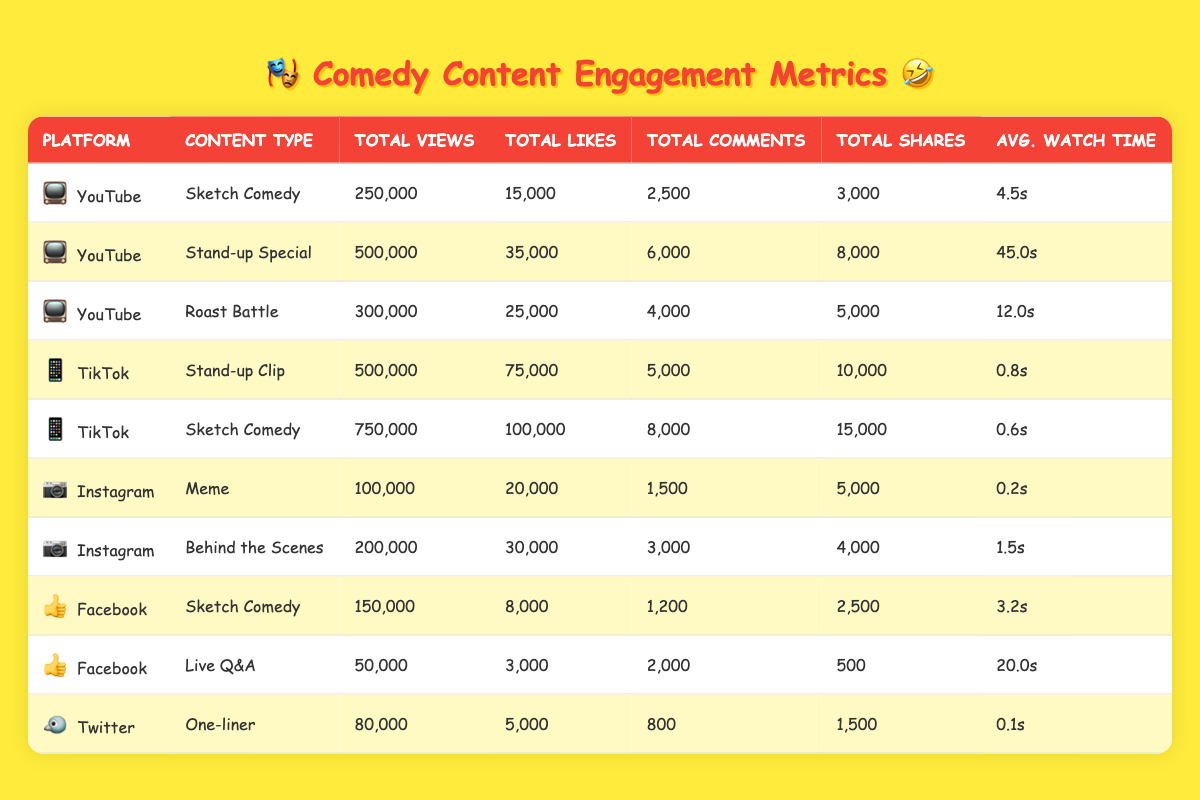What is the total number of views for TikTok content? From the data, the TikTok content consists of two entries: one for "When Your Cat Judges You" with 500,000 views and another for "Mace & Burton's TikTok Dance Fail," which has 750,000 views. Adding these two together gives 500,000 + 750,000 = 1,250,000 views.
Answer: 1,250,000 Which content type received the highest number of likes? The likes data shows that the TikTok sketch comedy video "Mace & Burton's TikTok Dance Fail" received 100,000 likes, which is more than any other content type in the table. The next highest is the YouTube stand-up clip with 75,000 likes. Thus, the highest likes were 100,000.
Answer: 100,000 Did any video receive more than 1,000 shares, and if so, which one had the highest shares? Checking the shares column, the TikTok sketch comedy video has 15,000 shares, which is significantly higher than the others, all of which also exceed 1,000 shares. The video "Mace & Burton's TikTok Dance Fail" holds the highest with 15,000 shares.
Answer: Yes, "Mace & Burton's TikTok Dance Fail" had the highest shares with 15,000 What is the average watch time for YouTube content? The YouTube entries include three videos: "Grocery Store Mishap" with 4.5 seconds, "Life as Mace & Burton's Sidekick" with 45 seconds, and "Roasting Mace & Burton" with 12 seconds. First, we calculate the total watch time: 4.5 + 45 + 12 = 61.5 seconds. Since there are three videos, we divide by 3: 61.5 / 3 = 20.5 seconds.
Answer: 20.5 seconds Is there a video on Instagram that received more likes than any on Facebook? Looking at the Instagram data, the "Behind the Scenes" video received 30,000 likes, while the highest on Facebook, which is "Mace & Burton's Office Space Parody," received 8,000 likes. Thus, the Instagram video had more likes than any on Facebook.
Answer: Yes, the Instagram video received more likes 